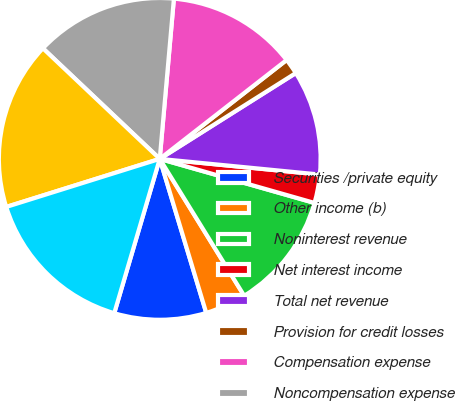Convert chart. <chart><loc_0><loc_0><loc_500><loc_500><pie_chart><fcel>Securities /private equity<fcel>Other income (b)<fcel>Noninterest revenue<fcel>Net interest income<fcel>Total net revenue<fcel>Provision for credit losses<fcel>Compensation expense<fcel>Noncompensation expense<fcel>Subtotal<fcel>Net expenses allocated to<nl><fcel>9.23%<fcel>4.13%<fcel>11.79%<fcel>2.86%<fcel>10.51%<fcel>1.58%<fcel>13.06%<fcel>14.34%<fcel>16.89%<fcel>15.61%<nl></chart> 